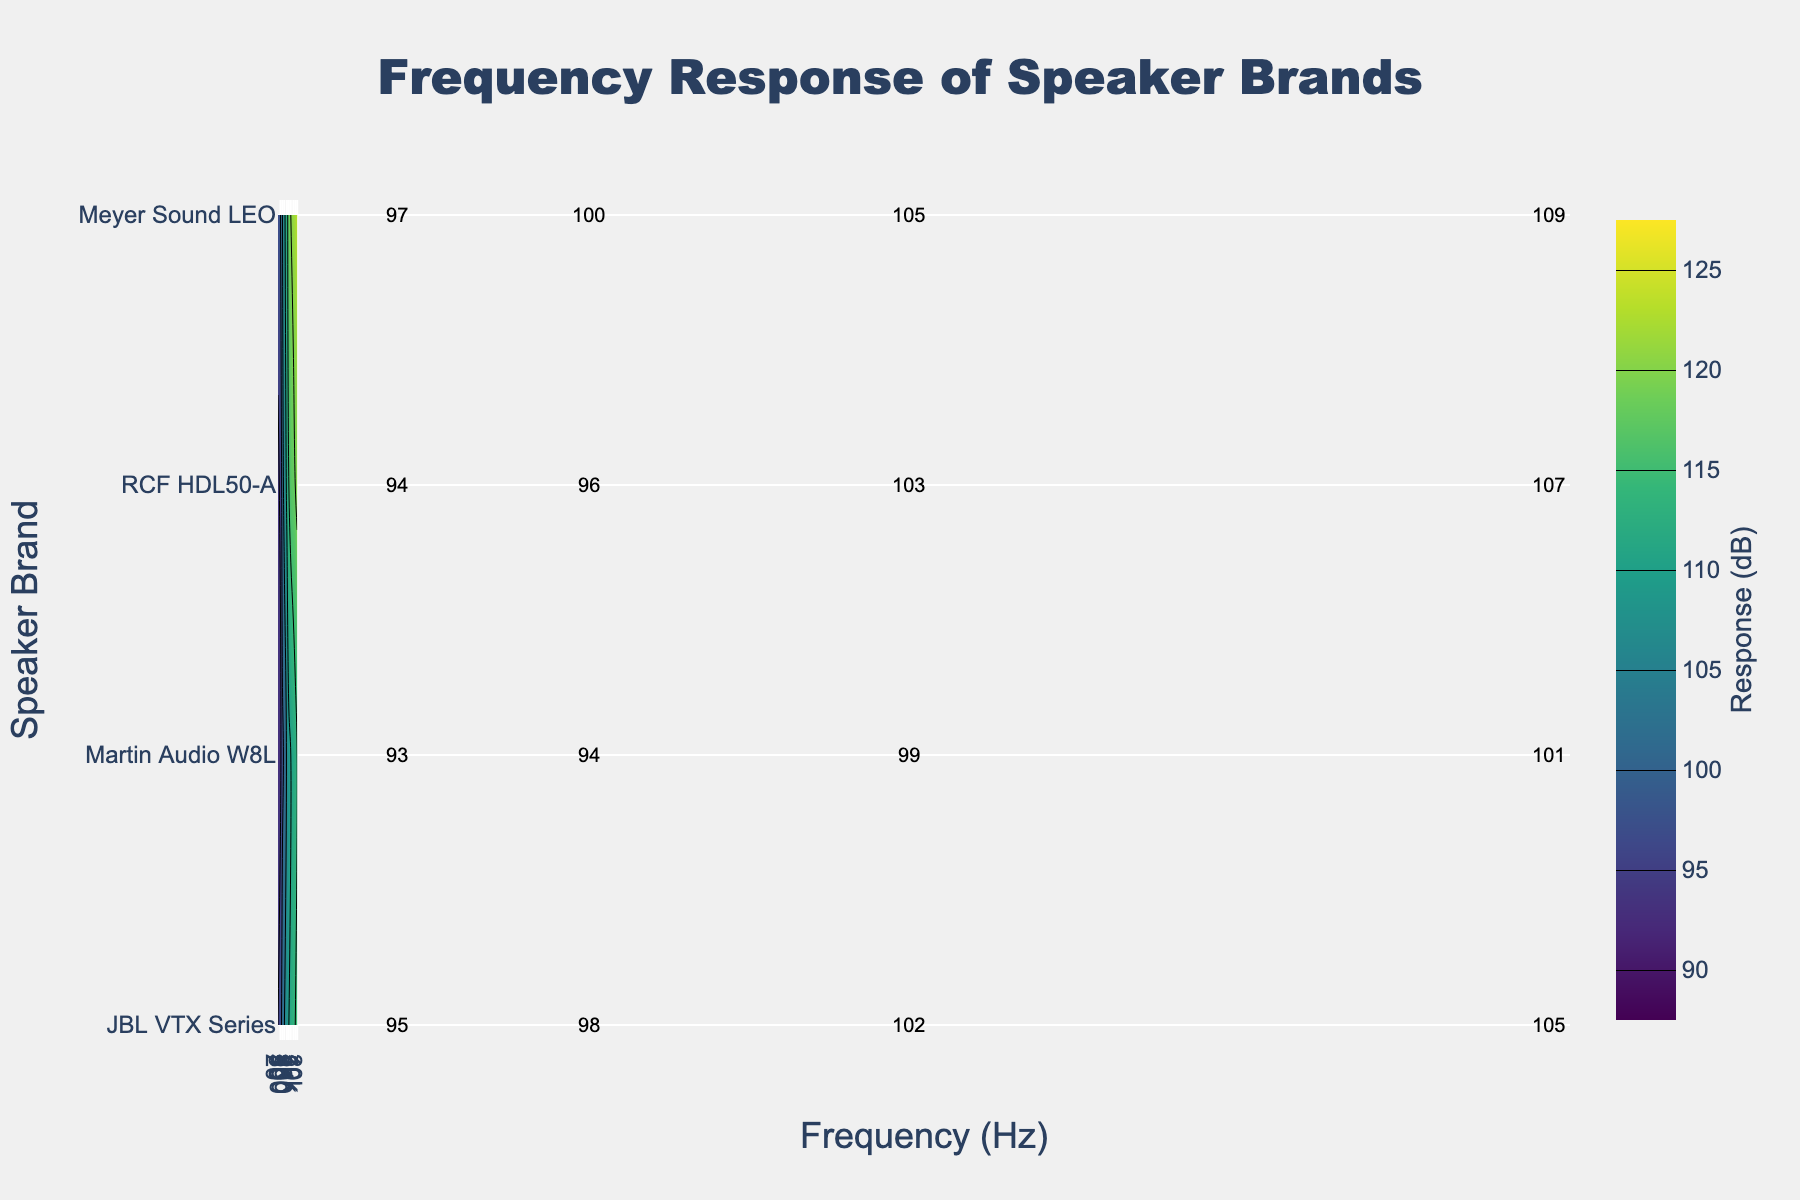What is the title of the plot? The title is usually displayed at the top of the plot. In this case, the title is specified as "Frequency Response of Speaker Brands".
Answer: Frequency Response of Speaker Brands Which speaker brand shows the highest frequency response at 1000 Hz? Look at the contour plot at the 1000 Hz mark and find the brand with the highest dB response. Meyer Sound LEO shows the highest response at 1000 Hz.
Answer: Meyer Sound LEO At which frequency does the RCF HDL50-A speaker brand have a response of approximately 120 dB? Observing the RCF HDL50-A contour band and checking where it intersects the 120 dB line. This occurs around 10000 Hz.
Answer: 10000 Hz How does the frequency response of Meyer Sound LEO change from 50 Hz to 200 Hz? Compare the dB response values for Meyer Sound LEO at 50 Hz (100 dB) and 200 Hz (109 dB). Compute the difference, which is 109 - 100.
Answer: 9 dB increase Which speaker brand has the least frequency response variation across the spectrum? Evaluate the spread of the contour bands for each brand and note the range of dB levels. Martin Audio W8L has the smallest range from 93 dB at 20 Hz to 115 dB at 20000 Hz.
Answer: Martin Audio W8L Between 5000 Hz and 20000 Hz, which speaker brand consistently has the highest response? Trace the responses of all brands in this frequency range and identify the one with the consistently highest dB values. Meyer Sound LEO remains the highest consistently.
Answer: Meyer Sound LEO By how many dB does the JBL VTX Series frequency response increase from 100 Hz to 1000 Hz? Extract the dB values for JBL VTX Series at 100 Hz (102 dB) and 1000 Hz (110 dB), and calculate the increase, which is 110 - 102.
Answer: 8 dB What is the color used for the highest response levels in the contour plot? In contour plots, color indicates different response levels. The color palette used is 'Viridis', where the highest values are yellowish. The highest levels are thus yellowish.
Answer: Yellowish At 200 Hz, which speaker brand has the second highest frequency response? Identify the dB values of each brand at 200 Hz and find the second highest value. Meyer Sound LEO is highest (109 dB), followed by RCF HDL50-A (107 dB).
Answer: RCF HDL50-A 